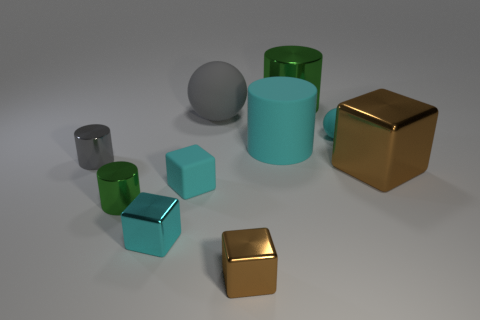Do the matte cube and the big matte cylinder have the same color?
Offer a very short reply. Yes. What color is the large cylinder that is behind the small cyan matte ball?
Keep it short and to the point. Green. What number of other things are the same size as the gray shiny cylinder?
Offer a terse response. 5. Are there the same number of rubber spheres behind the cyan ball and cyan metallic objects?
Keep it short and to the point. Yes. What number of tiny purple spheres have the same material as the large gray sphere?
Your answer should be compact. 0. What is the color of the other big ball that is made of the same material as the cyan sphere?
Ensure brevity in your answer.  Gray. Do the big cyan rubber object and the tiny green metallic object have the same shape?
Ensure brevity in your answer.  Yes. There is a cyan object that is in front of the green metallic thing that is in front of the gray metal thing; is there a cyan matte cylinder that is to the right of it?
Make the answer very short. Yes. How many other matte blocks are the same color as the tiny rubber cube?
Provide a succinct answer. 0. The cyan shiny object that is the same size as the gray cylinder is what shape?
Your answer should be very brief. Cube. 